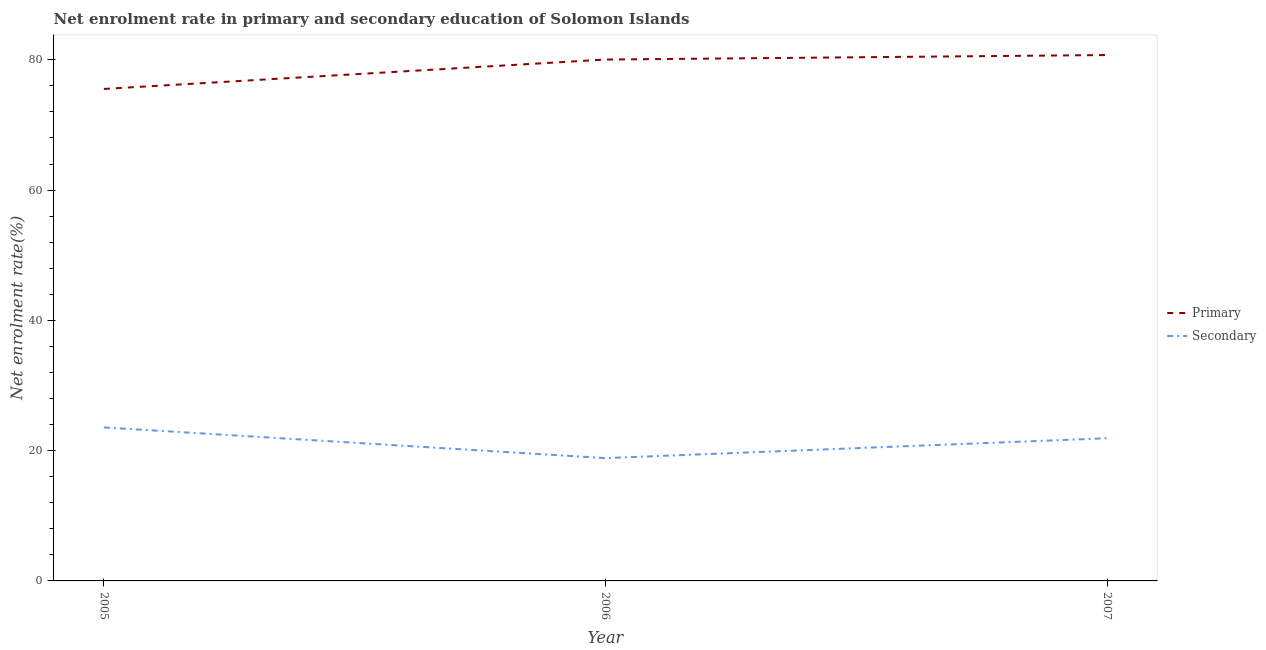Does the line corresponding to enrollment rate in secondary education intersect with the line corresponding to enrollment rate in primary education?
Give a very brief answer. No. What is the enrollment rate in primary education in 2007?
Offer a very short reply. 80.73. Across all years, what is the maximum enrollment rate in secondary education?
Your answer should be compact. 23.56. Across all years, what is the minimum enrollment rate in secondary education?
Give a very brief answer. 18.85. What is the total enrollment rate in primary education in the graph?
Make the answer very short. 236.29. What is the difference between the enrollment rate in secondary education in 2006 and that in 2007?
Give a very brief answer. -3.05. What is the difference between the enrollment rate in primary education in 2007 and the enrollment rate in secondary education in 2005?
Your answer should be very brief. 57.17. What is the average enrollment rate in secondary education per year?
Your answer should be compact. 21.44. In the year 2006, what is the difference between the enrollment rate in secondary education and enrollment rate in primary education?
Make the answer very short. -61.18. In how many years, is the enrollment rate in primary education greater than 76 %?
Offer a very short reply. 2. What is the ratio of the enrollment rate in primary education in 2005 to that in 2007?
Provide a succinct answer. 0.94. Is the enrollment rate in secondary education in 2006 less than that in 2007?
Your answer should be compact. Yes. What is the difference between the highest and the second highest enrollment rate in secondary education?
Provide a short and direct response. 1.66. What is the difference between the highest and the lowest enrollment rate in primary education?
Your answer should be compact. 5.2. In how many years, is the enrollment rate in primary education greater than the average enrollment rate in primary education taken over all years?
Keep it short and to the point. 2. Is the sum of the enrollment rate in secondary education in 2006 and 2007 greater than the maximum enrollment rate in primary education across all years?
Provide a succinct answer. No. Does the enrollment rate in secondary education monotonically increase over the years?
Your response must be concise. No. Is the enrollment rate in secondary education strictly greater than the enrollment rate in primary education over the years?
Provide a short and direct response. No. Is the enrollment rate in primary education strictly less than the enrollment rate in secondary education over the years?
Provide a succinct answer. No. How many lines are there?
Keep it short and to the point. 2. Are the values on the major ticks of Y-axis written in scientific E-notation?
Make the answer very short. No. Does the graph contain any zero values?
Make the answer very short. No. Where does the legend appear in the graph?
Your answer should be very brief. Center right. How many legend labels are there?
Your answer should be very brief. 2. What is the title of the graph?
Your response must be concise. Net enrolment rate in primary and secondary education of Solomon Islands. Does "Current US$" appear as one of the legend labels in the graph?
Your response must be concise. No. What is the label or title of the X-axis?
Your response must be concise. Year. What is the label or title of the Y-axis?
Your response must be concise. Net enrolment rate(%). What is the Net enrolment rate(%) in Primary in 2005?
Make the answer very short. 75.52. What is the Net enrolment rate(%) of Secondary in 2005?
Offer a very short reply. 23.56. What is the Net enrolment rate(%) of Primary in 2006?
Make the answer very short. 80.04. What is the Net enrolment rate(%) in Secondary in 2006?
Your answer should be very brief. 18.85. What is the Net enrolment rate(%) in Primary in 2007?
Offer a very short reply. 80.73. What is the Net enrolment rate(%) of Secondary in 2007?
Provide a succinct answer. 21.9. Across all years, what is the maximum Net enrolment rate(%) of Primary?
Ensure brevity in your answer.  80.73. Across all years, what is the maximum Net enrolment rate(%) of Secondary?
Ensure brevity in your answer.  23.56. Across all years, what is the minimum Net enrolment rate(%) of Primary?
Offer a terse response. 75.52. Across all years, what is the minimum Net enrolment rate(%) of Secondary?
Your answer should be very brief. 18.85. What is the total Net enrolment rate(%) in Primary in the graph?
Provide a succinct answer. 236.29. What is the total Net enrolment rate(%) in Secondary in the graph?
Offer a very short reply. 64.32. What is the difference between the Net enrolment rate(%) of Primary in 2005 and that in 2006?
Keep it short and to the point. -4.51. What is the difference between the Net enrolment rate(%) in Secondary in 2005 and that in 2006?
Offer a terse response. 4.71. What is the difference between the Net enrolment rate(%) of Primary in 2005 and that in 2007?
Offer a terse response. -5.2. What is the difference between the Net enrolment rate(%) of Secondary in 2005 and that in 2007?
Ensure brevity in your answer.  1.66. What is the difference between the Net enrolment rate(%) in Primary in 2006 and that in 2007?
Keep it short and to the point. -0.69. What is the difference between the Net enrolment rate(%) in Secondary in 2006 and that in 2007?
Provide a succinct answer. -3.05. What is the difference between the Net enrolment rate(%) of Primary in 2005 and the Net enrolment rate(%) of Secondary in 2006?
Your answer should be compact. 56.67. What is the difference between the Net enrolment rate(%) in Primary in 2005 and the Net enrolment rate(%) in Secondary in 2007?
Your answer should be compact. 53.62. What is the difference between the Net enrolment rate(%) in Primary in 2006 and the Net enrolment rate(%) in Secondary in 2007?
Offer a very short reply. 58.13. What is the average Net enrolment rate(%) in Primary per year?
Your answer should be compact. 78.76. What is the average Net enrolment rate(%) of Secondary per year?
Offer a terse response. 21.44. In the year 2005, what is the difference between the Net enrolment rate(%) of Primary and Net enrolment rate(%) of Secondary?
Make the answer very short. 51.96. In the year 2006, what is the difference between the Net enrolment rate(%) in Primary and Net enrolment rate(%) in Secondary?
Make the answer very short. 61.18. In the year 2007, what is the difference between the Net enrolment rate(%) of Primary and Net enrolment rate(%) of Secondary?
Keep it short and to the point. 58.82. What is the ratio of the Net enrolment rate(%) in Primary in 2005 to that in 2006?
Provide a succinct answer. 0.94. What is the ratio of the Net enrolment rate(%) in Secondary in 2005 to that in 2006?
Make the answer very short. 1.25. What is the ratio of the Net enrolment rate(%) in Primary in 2005 to that in 2007?
Your answer should be compact. 0.94. What is the ratio of the Net enrolment rate(%) in Secondary in 2005 to that in 2007?
Make the answer very short. 1.08. What is the ratio of the Net enrolment rate(%) of Secondary in 2006 to that in 2007?
Keep it short and to the point. 0.86. What is the difference between the highest and the second highest Net enrolment rate(%) in Primary?
Provide a succinct answer. 0.69. What is the difference between the highest and the second highest Net enrolment rate(%) in Secondary?
Your answer should be very brief. 1.66. What is the difference between the highest and the lowest Net enrolment rate(%) of Primary?
Offer a very short reply. 5.2. What is the difference between the highest and the lowest Net enrolment rate(%) in Secondary?
Your answer should be compact. 4.71. 